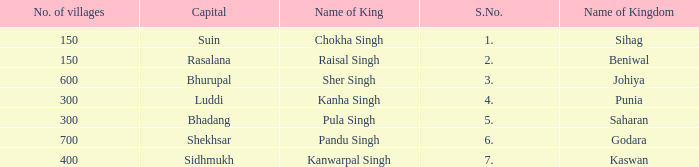Which kingdom has Suin as its capital? Sihag. 